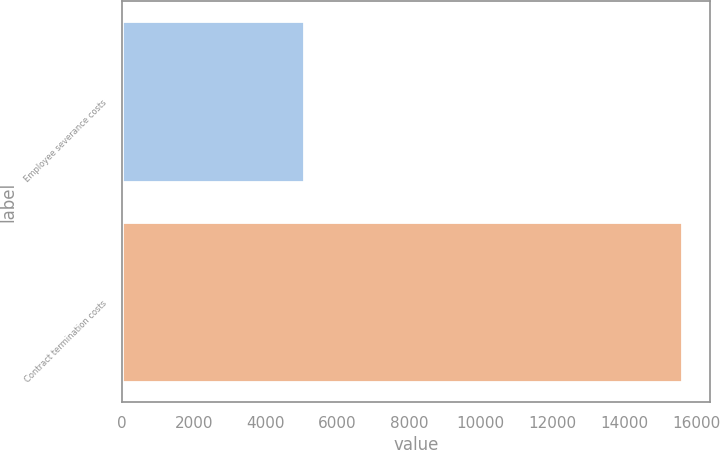<chart> <loc_0><loc_0><loc_500><loc_500><bar_chart><fcel>Employee severance costs<fcel>Contract termination costs<nl><fcel>5068<fcel>15594<nl></chart> 